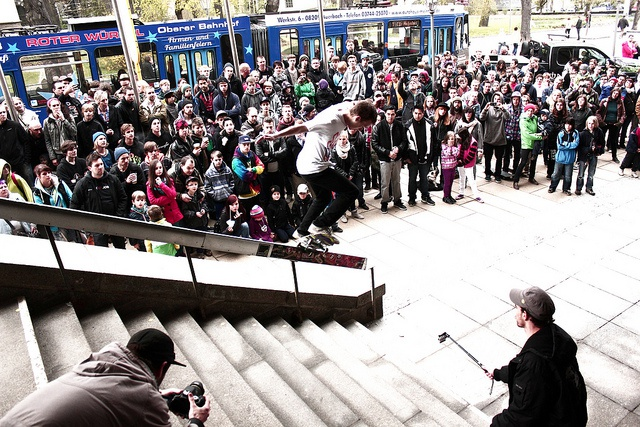Describe the objects in this image and their specific colors. I can see people in white, black, gray, and darkgray tones, bus in white, black, blue, and gray tones, people in white, black, lightgray, darkgray, and gray tones, people in white, black, lightgray, gray, and darkgray tones, and people in white, black, gray, and darkgray tones in this image. 